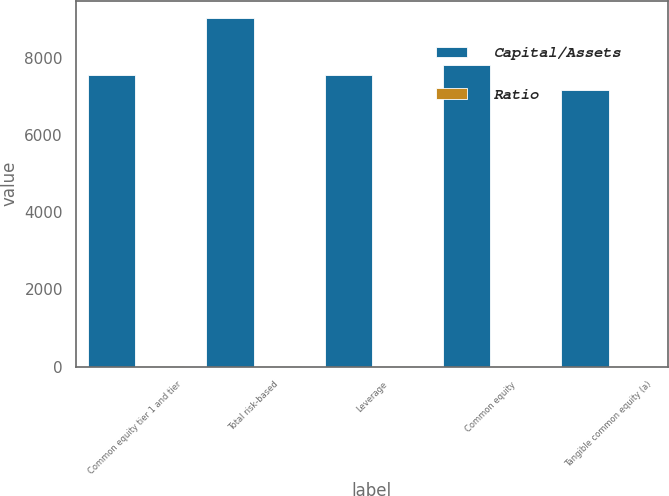Convert chart to OTSL. <chart><loc_0><loc_0><loc_500><loc_500><stacked_bar_chart><ecel><fcel>Common equity tier 1 and tier<fcel>Total risk-based<fcel>Leverage<fcel>Common equity<fcel>Tangible common equity (a)<nl><fcel>Capital/Assets<fcel>7540<fcel>9018<fcel>7540<fcel>7796<fcel>7151<nl><fcel>Ratio<fcel>11.09<fcel>13.27<fcel>10.18<fcel>10.68<fcel>9.89<nl></chart> 